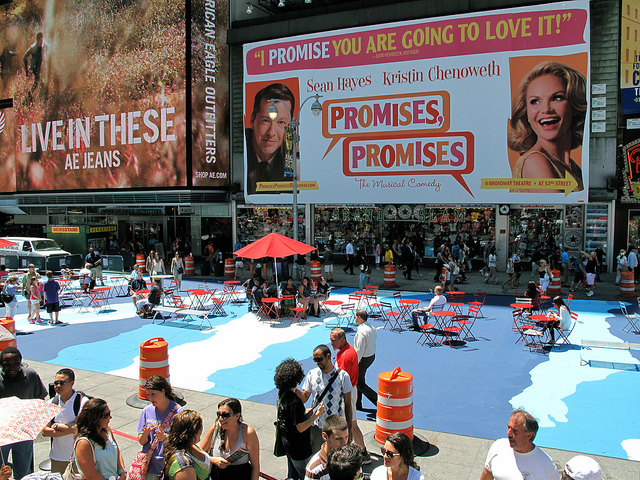Please extract the text content from this image. PROMISES PROMISES LIVE ARE PROMISE T C Comedy Musical IT LOVE TO GOING Chenoweth Kristin Hayes Sean YOU EAGLE RICAN AE JEANS THESE 